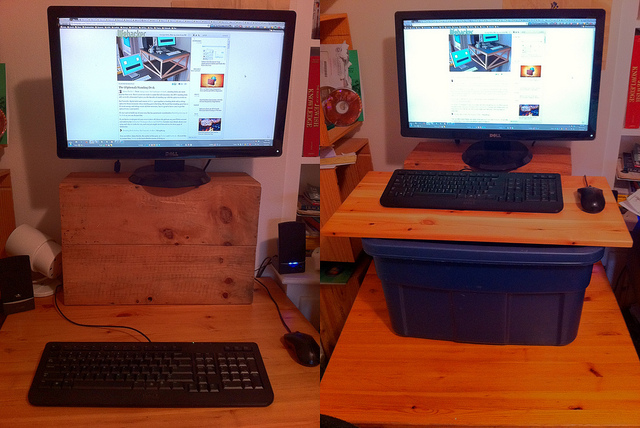<image>What is the difference between the position of the monitors? I don't know the exact difference between the position of the monitors. It can be seen one is higher than the other or one is at a closer distance. What is the difference between the position of the monitors? I don't know the exact difference between the position of the monitors. It is possible that one is higher than the other or one is closer in distance. 